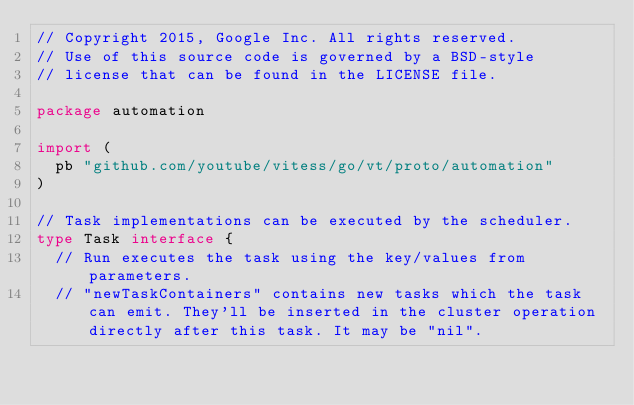Convert code to text. <code><loc_0><loc_0><loc_500><loc_500><_Go_>// Copyright 2015, Google Inc. All rights reserved.
// Use of this source code is governed by a BSD-style
// license that can be found in the LICENSE file.

package automation

import (
	pb "github.com/youtube/vitess/go/vt/proto/automation"
)

// Task implementations can be executed by the scheduler.
type Task interface {
	// Run executes the task using the key/values from parameters.
	// "newTaskContainers" contains new tasks which the task can emit. They'll be inserted in the cluster operation directly after this task. It may be "nil".</code> 